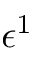Convert formula to latex. <formula><loc_0><loc_0><loc_500><loc_500>\epsilon ^ { 1 }</formula> 